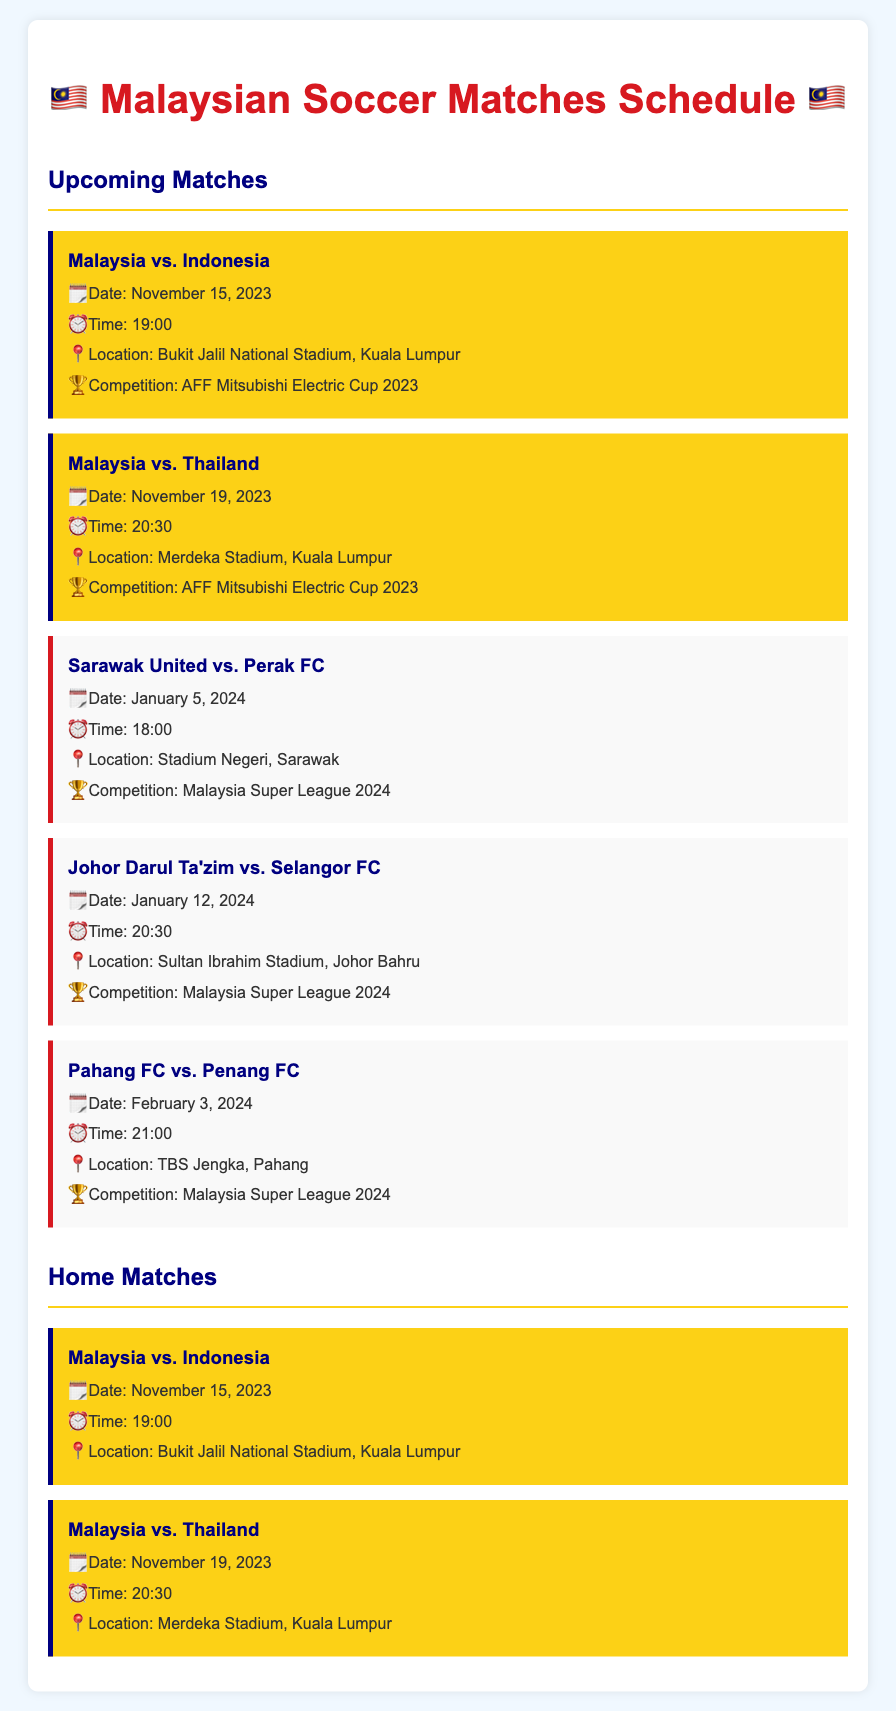What is the date of the match between Malaysia and Indonesia? The match between Malaysia and Indonesia is scheduled for November 15, 2023.
Answer: November 15, 2023 What time does the match between Malaysia and Thailand start? The match between Malaysia and Thailand starts at 20:30 on November 19, 2023.
Answer: 20:30 Where is the match between Sarawak United and Perak FC held? The match is held at Stadium Negeri, Sarawak on January 5, 2024.
Answer: Stadium Negeri, Sarawak How many home matches are listed in the document? There are 2 home matches listed in the document for Malaysia.
Answer: 2 What competition is the match between Johor Darul Ta'zim and Selangor FC part of? The match between Johor Darul Ta'zim and Selangor FC is part of the Malaysia Super League 2024.
Answer: Malaysia Super League 2024 Which state is the match between Pahang FC and Penang FC located in? The match is located in Pahang on February 3, 2024.
Answer: Pahang What is the title of the section containing the home matches? The section containing the home matches is titled "Home Matches".
Answer: Home Matches On what date will the AFF Mitsubishi Electric Cup 2023 start? The first match of the AFF Mitsubishi Electric Cup 2023 is on November 15, 2023.
Answer: November 15, 2023 